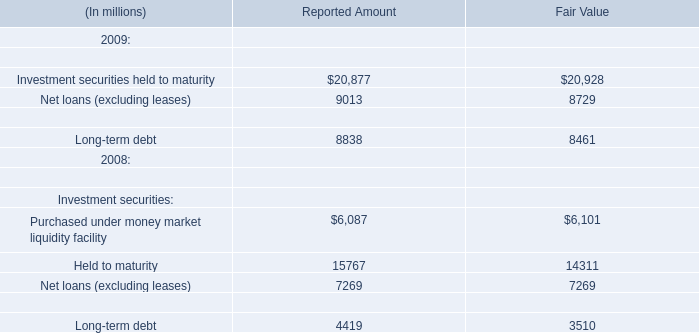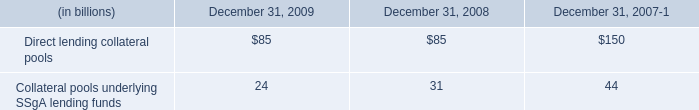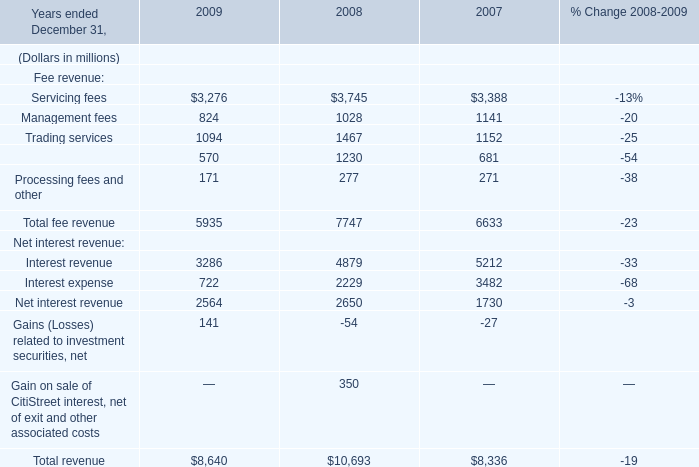what was the percent change in the aggregate net asset values of the direct lending collateral pools between 2007 and 2008? 
Computations: ((85 - 150) / 150)
Answer: -0.43333. 